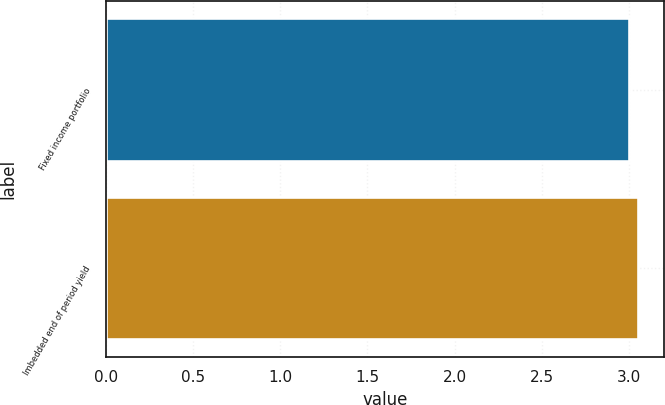<chart> <loc_0><loc_0><loc_500><loc_500><bar_chart><fcel>Fixed income portfolio<fcel>Imbedded end of period yield<nl><fcel>3<fcel>3.05<nl></chart> 